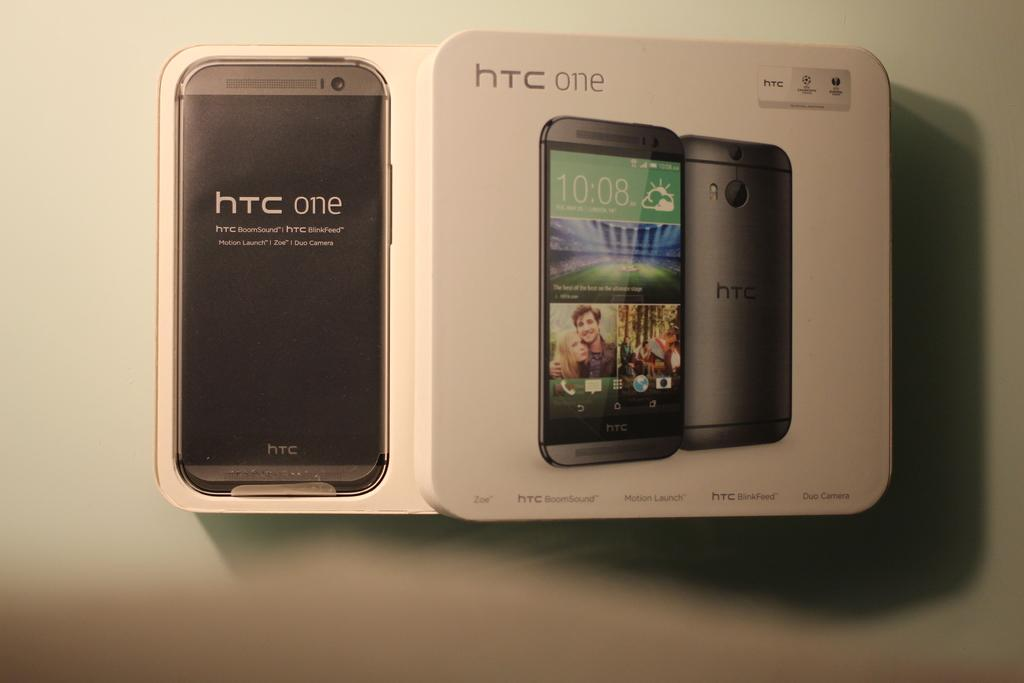<image>
Offer a succinct explanation of the picture presented. The white box contains a htc one mobile device. 